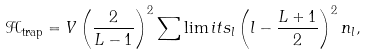<formula> <loc_0><loc_0><loc_500><loc_500>\mathcal { H } _ { \text {trap} } = V \left ( \frac { 2 } { L - 1 } \right ) ^ { 2 } \sum \lim i t s _ { l } \left ( l - \frac { L + 1 } { 2 } \right ) ^ { 2 } n _ { l } ,</formula> 